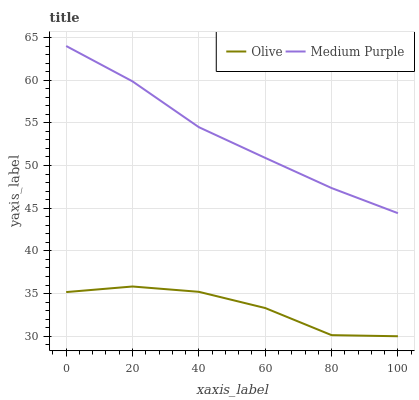Does Olive have the minimum area under the curve?
Answer yes or no. Yes. Does Medium Purple have the maximum area under the curve?
Answer yes or no. Yes. Does Medium Purple have the minimum area under the curve?
Answer yes or no. No. Is Medium Purple the smoothest?
Answer yes or no. Yes. Is Olive the roughest?
Answer yes or no. Yes. Is Medium Purple the roughest?
Answer yes or no. No. Does Olive have the lowest value?
Answer yes or no. Yes. Does Medium Purple have the lowest value?
Answer yes or no. No. Does Medium Purple have the highest value?
Answer yes or no. Yes. Is Olive less than Medium Purple?
Answer yes or no. Yes. Is Medium Purple greater than Olive?
Answer yes or no. Yes. Does Olive intersect Medium Purple?
Answer yes or no. No. 